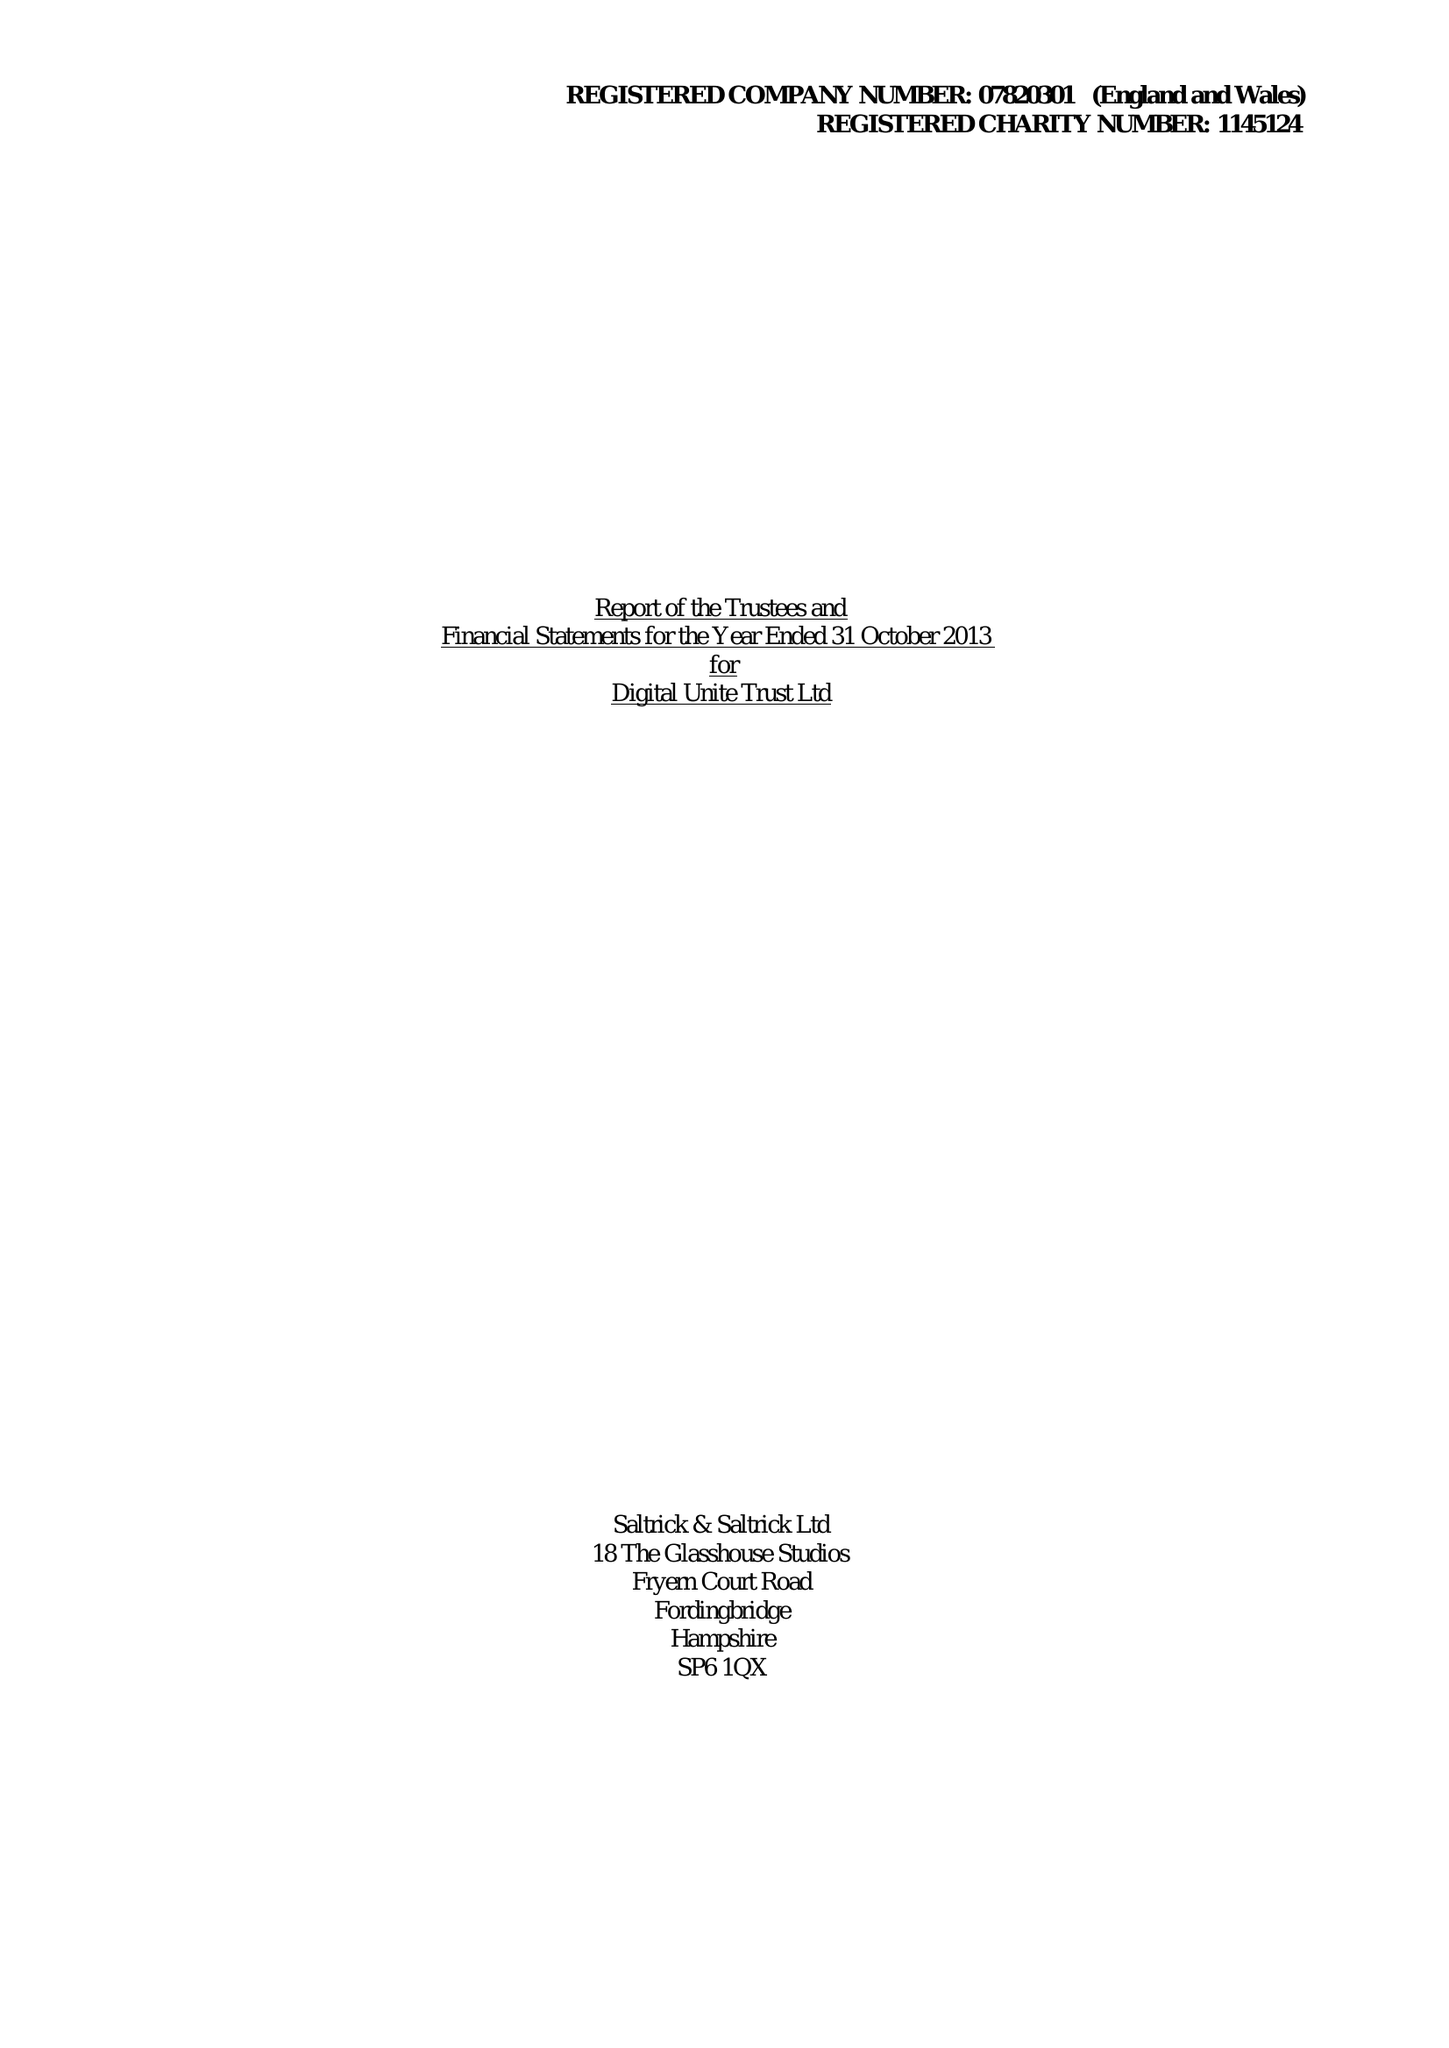What is the value for the report_date?
Answer the question using a single word or phrase. 2013-10-31 